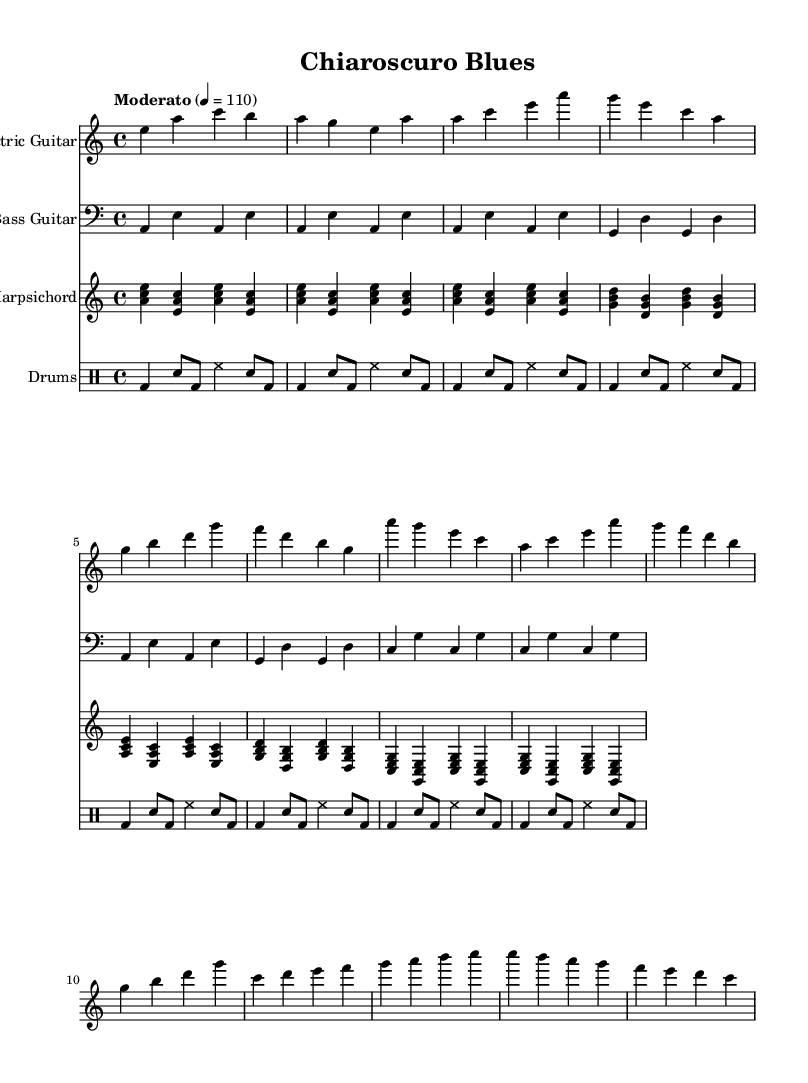What is the key signature of this music? The key signature is A minor, which has no sharps and no flats. This can be identified by looking at the beginning of the sheet music where the key signature is indicated.
Answer: A minor What is the time signature of the piece? The time signature is 4/4, meaning there are four beats in each measure and the quarter note receives one beat. This is visible at the beginning of the sheet music right next to the key signature.
Answer: 4/4 What is the tempo marking for this piece? The tempo marking is "Moderato," which indicates a moderate speed, specifically 110 beats per minute. The tempo is noted above the staff at the beginning of the piece.
Answer: Moderato What instruments are included in this composition? The composition includes Electric Guitar, Bass Guitar, Harpsichord, and Drums. This information can be found at the beginning of each staff where the instrument names are listed.
Answer: Electric Guitar, Bass Guitar, Harpsichord, Drums How many measures does the Electric Guitar part have? The Electric Guitar part contains 8 measures. By counting individual sections of music between the vertical bar lines on the staff, we can tally the total number of measures represented.
Answer: 8 Which Baroque musical element is incorporated in this piece? The Harpsichord represents the Baroque musical element in this piece, as it is a keyboard instrument commonly associated with that era. The specific musical style and elements of the harpsichord can be identified by examining the part designated for it.
Answer: Harpsichord What is the relationship between the Electric Guitar and the Harpsichord in the composition? The Electric Guitar part serves as a melodic and harmonic counterpart to the Harpsichord, creating a fusion of modern blues and Baroque textures. To understand this, one can analyze how both parts interact, with the Guitar often taking the lead while the Harpsichord provides harmonic support.
Answer: Fusion of modern blues and Baroque textures 